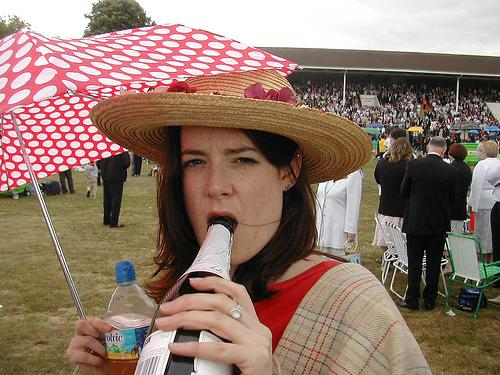Describe the type of hat worn by the woman and any decorations it might have. The woman is wearing a brown straw hat adorned with red flowers. Describe the setting of the photo in terms of weather and atmosphere. The setting appears to be outdoors, with a cloudy grey sky and people gathered in a stadium. What items can be seen under the lawn chair? A blue and black cooler is visible under the green and white lawn chair. What are the beverages the woman is carrying? The woman is carrying an open bottle of champagne and a water bottle holding juice. Please provide a short description of the umbrella in the image. The umbrella is red with white polka dots and opened. What type of event might be taking place in the background of the image? A sports event or a gathering in a stadium, with people sitting in the stands. Can you describe the appearance of the woman's eyes? The woman has dark, brown eyes. What is the woman holding in her hand apart from the bottle of wine? She is holding a water bottle filled with juice. Can you count how many people are dressed in formal black wear? There are two women and one man dressed in black formal wear. Identify the type of chair in the image and its colors. There is a green and white folding lawn chair in the image. 